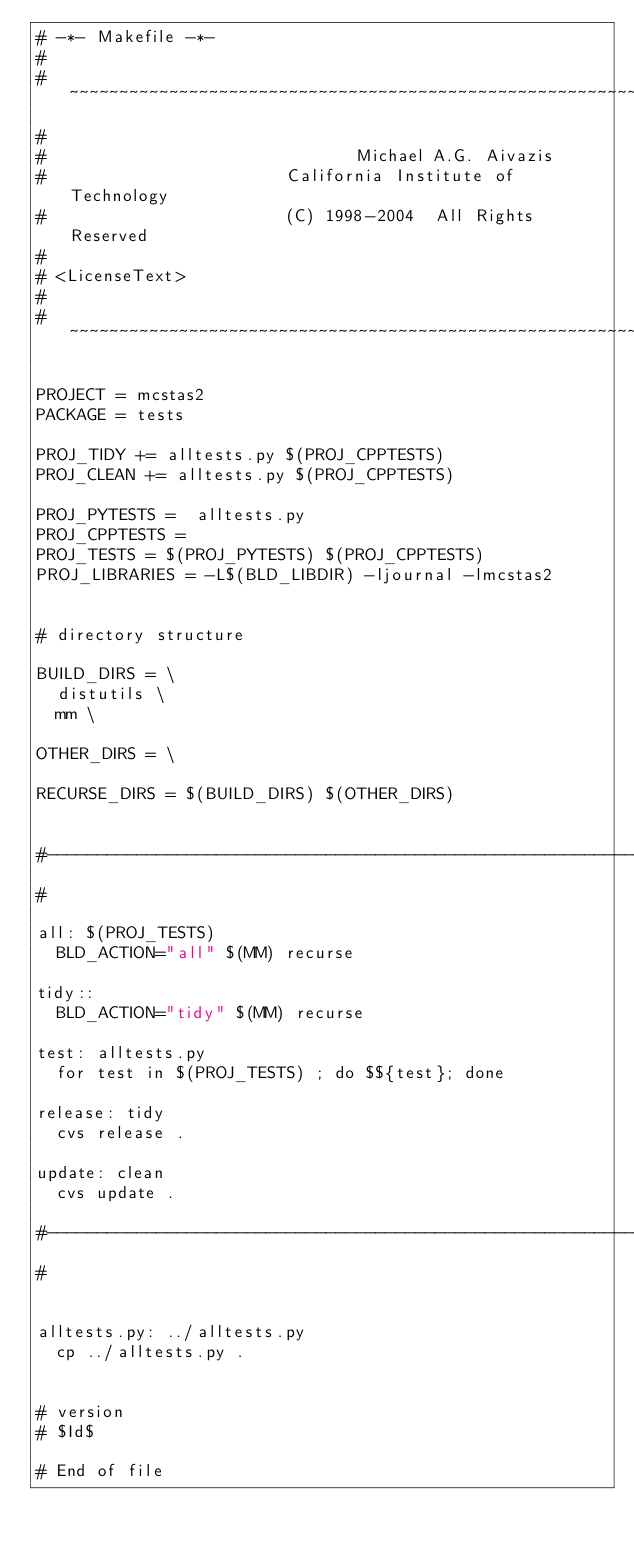<code> <loc_0><loc_0><loc_500><loc_500><_ObjectiveC_># -*- Makefile -*-
#
# ~~~~~~~~~~~~~~~~~~~~~~~~~~~~~~~~~~~~~~~~~~~~~~~~~~~~~~~~~~~~~~~~~~~~~~~~~~~~~~~~
#
#                               Michael A.G. Aivazis
#                        California Institute of Technology
#                        (C) 1998-2004  All Rights Reserved
#
# <LicenseText>
#
# ~~~~~~~~~~~~~~~~~~~~~~~~~~~~~~~~~~~~~~~~~~~~~~~~~~~~~~~~~~~~~~~~~~~~~~~~~~~~~~~~

PROJECT = mcstas2
PACKAGE = tests

PROJ_TIDY += alltests.py $(PROJ_CPPTESTS)
PROJ_CLEAN += alltests.py $(PROJ_CPPTESTS)

PROJ_PYTESTS =  alltests.py
PROJ_CPPTESTS = 
PROJ_TESTS = $(PROJ_PYTESTS) $(PROJ_CPPTESTS)
PROJ_LIBRARIES = -L$(BLD_LIBDIR) -ljournal -lmcstas2


# directory structure

BUILD_DIRS = \
	distutils \
	mm \

OTHER_DIRS = \

RECURSE_DIRS = $(BUILD_DIRS) $(OTHER_DIRS)


#--------------------------------------------------------------------------
#

all: $(PROJ_TESTS)
	BLD_ACTION="all" $(MM) recurse

tidy::
	BLD_ACTION="tidy" $(MM) recurse

test: alltests.py
	for test in $(PROJ_TESTS) ; do $${test}; done

release: tidy
	cvs release .

update: clean
	cvs update .

#--------------------------------------------------------------------------
#


alltests.py: ../alltests.py
	cp ../alltests.py .


# version
# $Id$

# End of file
</code> 